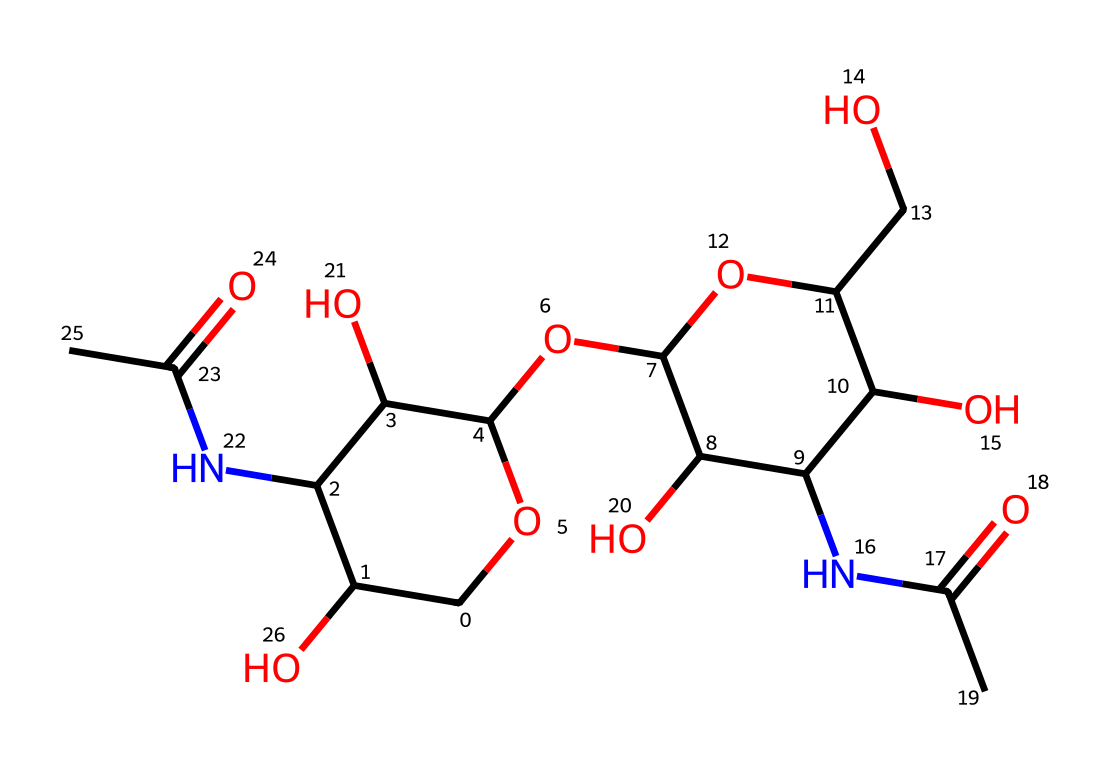What is the molecular formula of this chemical? By examining the structure of the compound represented by the SMILES notation, we can count the individual atoms of each element present in the structure. Specifically, we would look for carbon (C), hydrogen (H), oxygen (O), and nitrogen (N) atoms. In this case, counting gives us a molecular formula of C8H14N2O8.
Answer: C8H14N2O8 How many nitrogen atoms are in this chemical? From the visual representation, we can identify nitrogen atoms by their symbols in the structure. In this case, upon examining the structure, we note that there are two nitrogen atoms present.
Answer: 2 What type of polymer is represented by this chemical? The structure indicates that this compound is derived from chitin and is chitosan. Chitosan is a biopolymer formed by the deacetylation of chitin, which is obtained from shellfish.
Answer: chitosan Does this chemical contain any functional groups? A thorough analysis of the structural representation reveals multiple functional groups, particularly hydroxyl (-OH) groups and an amine (-NH-) group, which contribute to its chemical properties and reactivity.
Answer: yes What is the potential application of this chemical in water treatment? Chitosan, as represented by this chemical structure, is known for its effectiveness as a flocculant, which helps in the removal of impurities and contaminants in water treatment processes.
Answer: flocculant How does this chemical behave as a non-Newtonian fluid? The polymeric structure of chitosan allows it to change viscosity under stress, characteristic of non-Newtonian fluids. When shear is applied, it can flow more easily, thus altering its viscosity based on the mechanical load.
Answer: changes viscosity Does this chemical have any antibacterial properties? The presence of amine groups in the structure of chitosan contributes to its antimicrobial properties, making it effective in inhibiting the growth of certain bacteria and fungi.
Answer: yes 